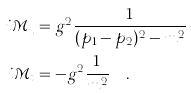Convert formula to latex. <formula><loc_0><loc_0><loc_500><loc_500>i \mathcal { M } _ { u } & = g ^ { 2 } \frac { 1 } { ( p _ { 1 } - p _ { 2 } ) ^ { 2 } - m ^ { 2 } } \\ i \mathcal { M } _ { t } & = - g ^ { 2 } \frac { 1 } { m ^ { 2 } } \quad .</formula> 